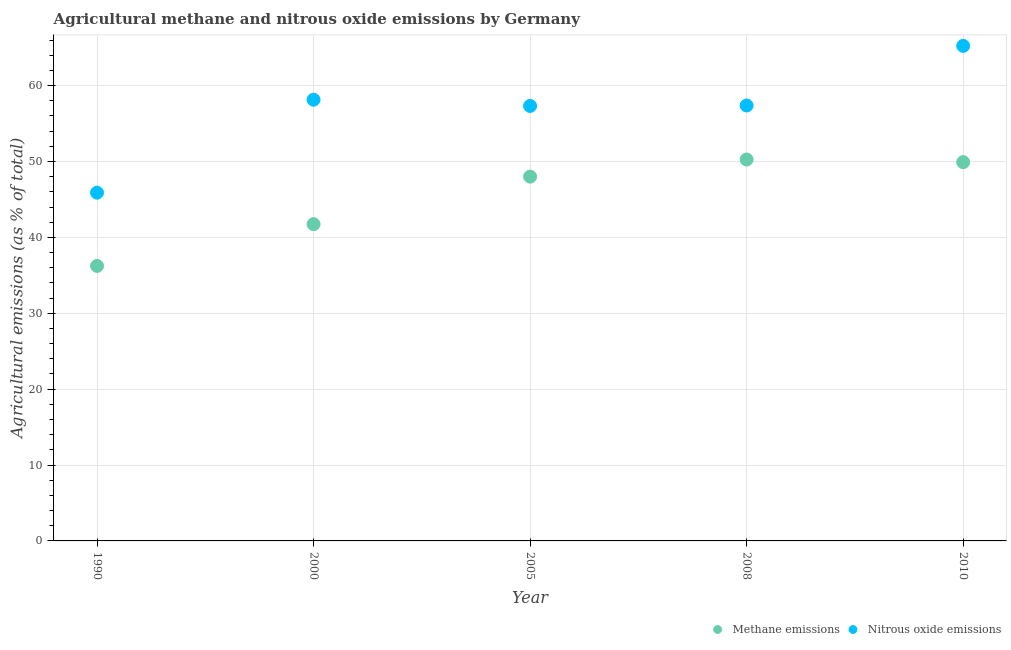How many different coloured dotlines are there?
Make the answer very short. 2. Is the number of dotlines equal to the number of legend labels?
Offer a very short reply. Yes. What is the amount of methane emissions in 1990?
Give a very brief answer. 36.24. Across all years, what is the maximum amount of nitrous oxide emissions?
Provide a succinct answer. 65.23. Across all years, what is the minimum amount of nitrous oxide emissions?
Make the answer very short. 45.89. In which year was the amount of nitrous oxide emissions maximum?
Provide a succinct answer. 2010. In which year was the amount of methane emissions minimum?
Your response must be concise. 1990. What is the total amount of nitrous oxide emissions in the graph?
Provide a succinct answer. 283.97. What is the difference between the amount of nitrous oxide emissions in 2005 and that in 2008?
Offer a terse response. -0.06. What is the difference between the amount of methane emissions in 1990 and the amount of nitrous oxide emissions in 2008?
Offer a very short reply. -21.14. What is the average amount of methane emissions per year?
Your response must be concise. 45.23. In the year 2010, what is the difference between the amount of nitrous oxide emissions and amount of methane emissions?
Offer a terse response. 15.32. What is the ratio of the amount of nitrous oxide emissions in 1990 to that in 2005?
Provide a short and direct response. 0.8. What is the difference between the highest and the second highest amount of methane emissions?
Make the answer very short. 0.35. What is the difference between the highest and the lowest amount of methane emissions?
Provide a succinct answer. 14.02. In how many years, is the amount of nitrous oxide emissions greater than the average amount of nitrous oxide emissions taken over all years?
Provide a succinct answer. 4. Does the amount of nitrous oxide emissions monotonically increase over the years?
Your answer should be compact. No. How many years are there in the graph?
Your answer should be compact. 5. Does the graph contain any zero values?
Ensure brevity in your answer.  No. Does the graph contain grids?
Offer a terse response. Yes. How are the legend labels stacked?
Offer a terse response. Horizontal. What is the title of the graph?
Keep it short and to the point. Agricultural methane and nitrous oxide emissions by Germany. Does "Agricultural land" appear as one of the legend labels in the graph?
Make the answer very short. No. What is the label or title of the Y-axis?
Make the answer very short. Agricultural emissions (as % of total). What is the Agricultural emissions (as % of total) in Methane emissions in 1990?
Your answer should be very brief. 36.24. What is the Agricultural emissions (as % of total) in Nitrous oxide emissions in 1990?
Provide a short and direct response. 45.89. What is the Agricultural emissions (as % of total) in Methane emissions in 2000?
Your response must be concise. 41.74. What is the Agricultural emissions (as % of total) of Nitrous oxide emissions in 2000?
Your answer should be very brief. 58.14. What is the Agricultural emissions (as % of total) in Methane emissions in 2005?
Provide a succinct answer. 48. What is the Agricultural emissions (as % of total) in Nitrous oxide emissions in 2005?
Offer a very short reply. 57.32. What is the Agricultural emissions (as % of total) of Methane emissions in 2008?
Offer a very short reply. 50.26. What is the Agricultural emissions (as % of total) of Nitrous oxide emissions in 2008?
Ensure brevity in your answer.  57.38. What is the Agricultural emissions (as % of total) in Methane emissions in 2010?
Your answer should be very brief. 49.91. What is the Agricultural emissions (as % of total) in Nitrous oxide emissions in 2010?
Offer a very short reply. 65.23. Across all years, what is the maximum Agricultural emissions (as % of total) in Methane emissions?
Provide a succinct answer. 50.26. Across all years, what is the maximum Agricultural emissions (as % of total) in Nitrous oxide emissions?
Offer a very short reply. 65.23. Across all years, what is the minimum Agricultural emissions (as % of total) in Methane emissions?
Provide a succinct answer. 36.24. Across all years, what is the minimum Agricultural emissions (as % of total) of Nitrous oxide emissions?
Provide a succinct answer. 45.89. What is the total Agricultural emissions (as % of total) in Methane emissions in the graph?
Your response must be concise. 226.16. What is the total Agricultural emissions (as % of total) of Nitrous oxide emissions in the graph?
Provide a succinct answer. 283.97. What is the difference between the Agricultural emissions (as % of total) in Methane emissions in 1990 and that in 2000?
Give a very brief answer. -5.5. What is the difference between the Agricultural emissions (as % of total) in Nitrous oxide emissions in 1990 and that in 2000?
Your response must be concise. -12.25. What is the difference between the Agricultural emissions (as % of total) in Methane emissions in 1990 and that in 2005?
Provide a succinct answer. -11.77. What is the difference between the Agricultural emissions (as % of total) in Nitrous oxide emissions in 1990 and that in 2005?
Offer a very short reply. -11.43. What is the difference between the Agricultural emissions (as % of total) in Methane emissions in 1990 and that in 2008?
Keep it short and to the point. -14.02. What is the difference between the Agricultural emissions (as % of total) in Nitrous oxide emissions in 1990 and that in 2008?
Make the answer very short. -11.49. What is the difference between the Agricultural emissions (as % of total) of Methane emissions in 1990 and that in 2010?
Offer a terse response. -13.67. What is the difference between the Agricultural emissions (as % of total) of Nitrous oxide emissions in 1990 and that in 2010?
Provide a succinct answer. -19.34. What is the difference between the Agricultural emissions (as % of total) in Methane emissions in 2000 and that in 2005?
Your response must be concise. -6.26. What is the difference between the Agricultural emissions (as % of total) of Nitrous oxide emissions in 2000 and that in 2005?
Provide a short and direct response. 0.82. What is the difference between the Agricultural emissions (as % of total) of Methane emissions in 2000 and that in 2008?
Ensure brevity in your answer.  -8.52. What is the difference between the Agricultural emissions (as % of total) in Nitrous oxide emissions in 2000 and that in 2008?
Provide a short and direct response. 0.76. What is the difference between the Agricultural emissions (as % of total) in Methane emissions in 2000 and that in 2010?
Make the answer very short. -8.17. What is the difference between the Agricultural emissions (as % of total) of Nitrous oxide emissions in 2000 and that in 2010?
Ensure brevity in your answer.  -7.09. What is the difference between the Agricultural emissions (as % of total) in Methane emissions in 2005 and that in 2008?
Ensure brevity in your answer.  -2.26. What is the difference between the Agricultural emissions (as % of total) in Nitrous oxide emissions in 2005 and that in 2008?
Ensure brevity in your answer.  -0.06. What is the difference between the Agricultural emissions (as % of total) of Methane emissions in 2005 and that in 2010?
Offer a very short reply. -1.91. What is the difference between the Agricultural emissions (as % of total) in Nitrous oxide emissions in 2005 and that in 2010?
Provide a succinct answer. -7.91. What is the difference between the Agricultural emissions (as % of total) in Methane emissions in 2008 and that in 2010?
Keep it short and to the point. 0.35. What is the difference between the Agricultural emissions (as % of total) in Nitrous oxide emissions in 2008 and that in 2010?
Provide a short and direct response. -7.86. What is the difference between the Agricultural emissions (as % of total) of Methane emissions in 1990 and the Agricultural emissions (as % of total) of Nitrous oxide emissions in 2000?
Make the answer very short. -21.9. What is the difference between the Agricultural emissions (as % of total) in Methane emissions in 1990 and the Agricultural emissions (as % of total) in Nitrous oxide emissions in 2005?
Offer a very short reply. -21.08. What is the difference between the Agricultural emissions (as % of total) of Methane emissions in 1990 and the Agricultural emissions (as % of total) of Nitrous oxide emissions in 2008?
Provide a succinct answer. -21.14. What is the difference between the Agricultural emissions (as % of total) in Methane emissions in 1990 and the Agricultural emissions (as % of total) in Nitrous oxide emissions in 2010?
Offer a very short reply. -29. What is the difference between the Agricultural emissions (as % of total) in Methane emissions in 2000 and the Agricultural emissions (as % of total) in Nitrous oxide emissions in 2005?
Make the answer very short. -15.58. What is the difference between the Agricultural emissions (as % of total) in Methane emissions in 2000 and the Agricultural emissions (as % of total) in Nitrous oxide emissions in 2008?
Offer a very short reply. -15.64. What is the difference between the Agricultural emissions (as % of total) of Methane emissions in 2000 and the Agricultural emissions (as % of total) of Nitrous oxide emissions in 2010?
Offer a terse response. -23.49. What is the difference between the Agricultural emissions (as % of total) in Methane emissions in 2005 and the Agricultural emissions (as % of total) in Nitrous oxide emissions in 2008?
Your response must be concise. -9.37. What is the difference between the Agricultural emissions (as % of total) of Methane emissions in 2005 and the Agricultural emissions (as % of total) of Nitrous oxide emissions in 2010?
Provide a short and direct response. -17.23. What is the difference between the Agricultural emissions (as % of total) in Methane emissions in 2008 and the Agricultural emissions (as % of total) in Nitrous oxide emissions in 2010?
Keep it short and to the point. -14.97. What is the average Agricultural emissions (as % of total) of Methane emissions per year?
Provide a short and direct response. 45.23. What is the average Agricultural emissions (as % of total) in Nitrous oxide emissions per year?
Keep it short and to the point. 56.79. In the year 1990, what is the difference between the Agricultural emissions (as % of total) in Methane emissions and Agricultural emissions (as % of total) in Nitrous oxide emissions?
Make the answer very short. -9.65. In the year 2000, what is the difference between the Agricultural emissions (as % of total) of Methane emissions and Agricultural emissions (as % of total) of Nitrous oxide emissions?
Your answer should be very brief. -16.4. In the year 2005, what is the difference between the Agricultural emissions (as % of total) of Methane emissions and Agricultural emissions (as % of total) of Nitrous oxide emissions?
Your response must be concise. -9.32. In the year 2008, what is the difference between the Agricultural emissions (as % of total) in Methane emissions and Agricultural emissions (as % of total) in Nitrous oxide emissions?
Offer a very short reply. -7.12. In the year 2010, what is the difference between the Agricultural emissions (as % of total) of Methane emissions and Agricultural emissions (as % of total) of Nitrous oxide emissions?
Offer a terse response. -15.32. What is the ratio of the Agricultural emissions (as % of total) of Methane emissions in 1990 to that in 2000?
Your answer should be very brief. 0.87. What is the ratio of the Agricultural emissions (as % of total) in Nitrous oxide emissions in 1990 to that in 2000?
Your answer should be very brief. 0.79. What is the ratio of the Agricultural emissions (as % of total) in Methane emissions in 1990 to that in 2005?
Provide a succinct answer. 0.75. What is the ratio of the Agricultural emissions (as % of total) in Nitrous oxide emissions in 1990 to that in 2005?
Make the answer very short. 0.8. What is the ratio of the Agricultural emissions (as % of total) of Methane emissions in 1990 to that in 2008?
Your response must be concise. 0.72. What is the ratio of the Agricultural emissions (as % of total) in Nitrous oxide emissions in 1990 to that in 2008?
Ensure brevity in your answer.  0.8. What is the ratio of the Agricultural emissions (as % of total) in Methane emissions in 1990 to that in 2010?
Provide a succinct answer. 0.73. What is the ratio of the Agricultural emissions (as % of total) in Nitrous oxide emissions in 1990 to that in 2010?
Your answer should be very brief. 0.7. What is the ratio of the Agricultural emissions (as % of total) in Methane emissions in 2000 to that in 2005?
Provide a short and direct response. 0.87. What is the ratio of the Agricultural emissions (as % of total) in Nitrous oxide emissions in 2000 to that in 2005?
Give a very brief answer. 1.01. What is the ratio of the Agricultural emissions (as % of total) in Methane emissions in 2000 to that in 2008?
Your response must be concise. 0.83. What is the ratio of the Agricultural emissions (as % of total) of Nitrous oxide emissions in 2000 to that in 2008?
Make the answer very short. 1.01. What is the ratio of the Agricultural emissions (as % of total) of Methane emissions in 2000 to that in 2010?
Give a very brief answer. 0.84. What is the ratio of the Agricultural emissions (as % of total) in Nitrous oxide emissions in 2000 to that in 2010?
Offer a very short reply. 0.89. What is the ratio of the Agricultural emissions (as % of total) of Methane emissions in 2005 to that in 2008?
Keep it short and to the point. 0.96. What is the ratio of the Agricultural emissions (as % of total) of Methane emissions in 2005 to that in 2010?
Ensure brevity in your answer.  0.96. What is the ratio of the Agricultural emissions (as % of total) of Nitrous oxide emissions in 2005 to that in 2010?
Make the answer very short. 0.88. What is the ratio of the Agricultural emissions (as % of total) in Nitrous oxide emissions in 2008 to that in 2010?
Offer a terse response. 0.88. What is the difference between the highest and the second highest Agricultural emissions (as % of total) of Methane emissions?
Offer a very short reply. 0.35. What is the difference between the highest and the second highest Agricultural emissions (as % of total) in Nitrous oxide emissions?
Your answer should be compact. 7.09. What is the difference between the highest and the lowest Agricultural emissions (as % of total) in Methane emissions?
Keep it short and to the point. 14.02. What is the difference between the highest and the lowest Agricultural emissions (as % of total) of Nitrous oxide emissions?
Provide a short and direct response. 19.34. 